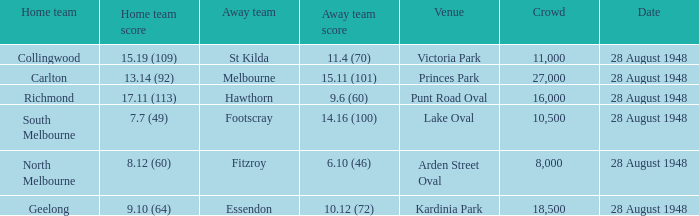What is the score for the st kilda away team? 11.4 (70). 